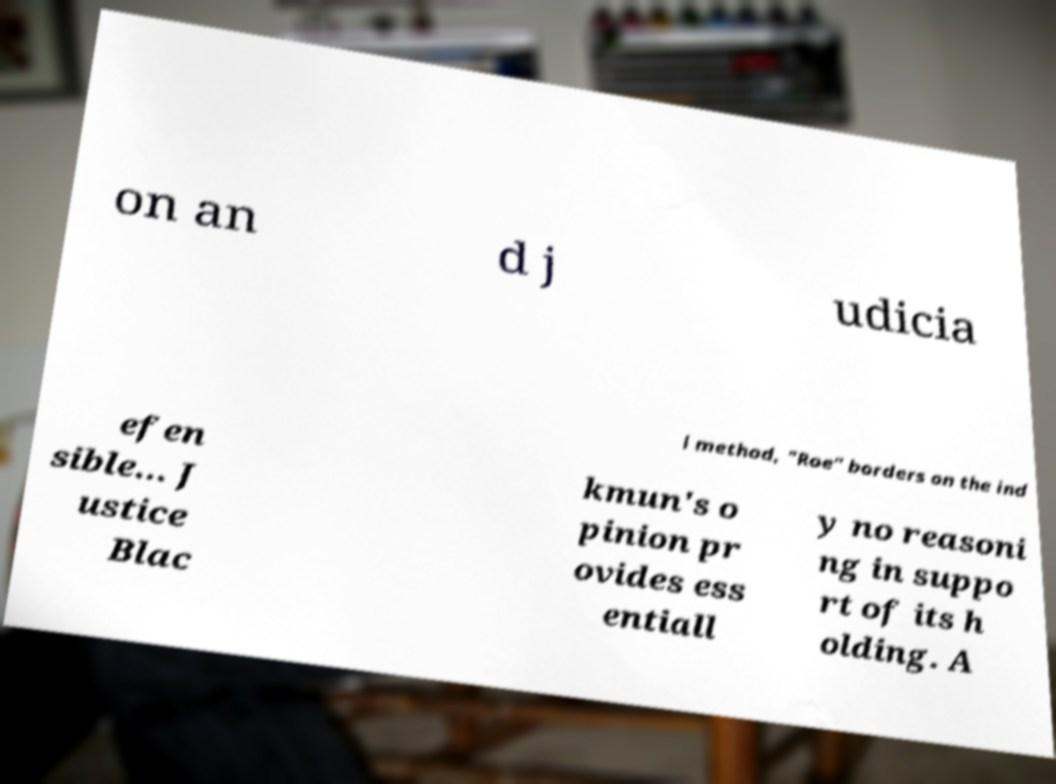Can you read and provide the text displayed in the image?This photo seems to have some interesting text. Can you extract and type it out for me? on an d j udicia l method, "Roe" borders on the ind efen sible... J ustice Blac kmun's o pinion pr ovides ess entiall y no reasoni ng in suppo rt of its h olding. A 